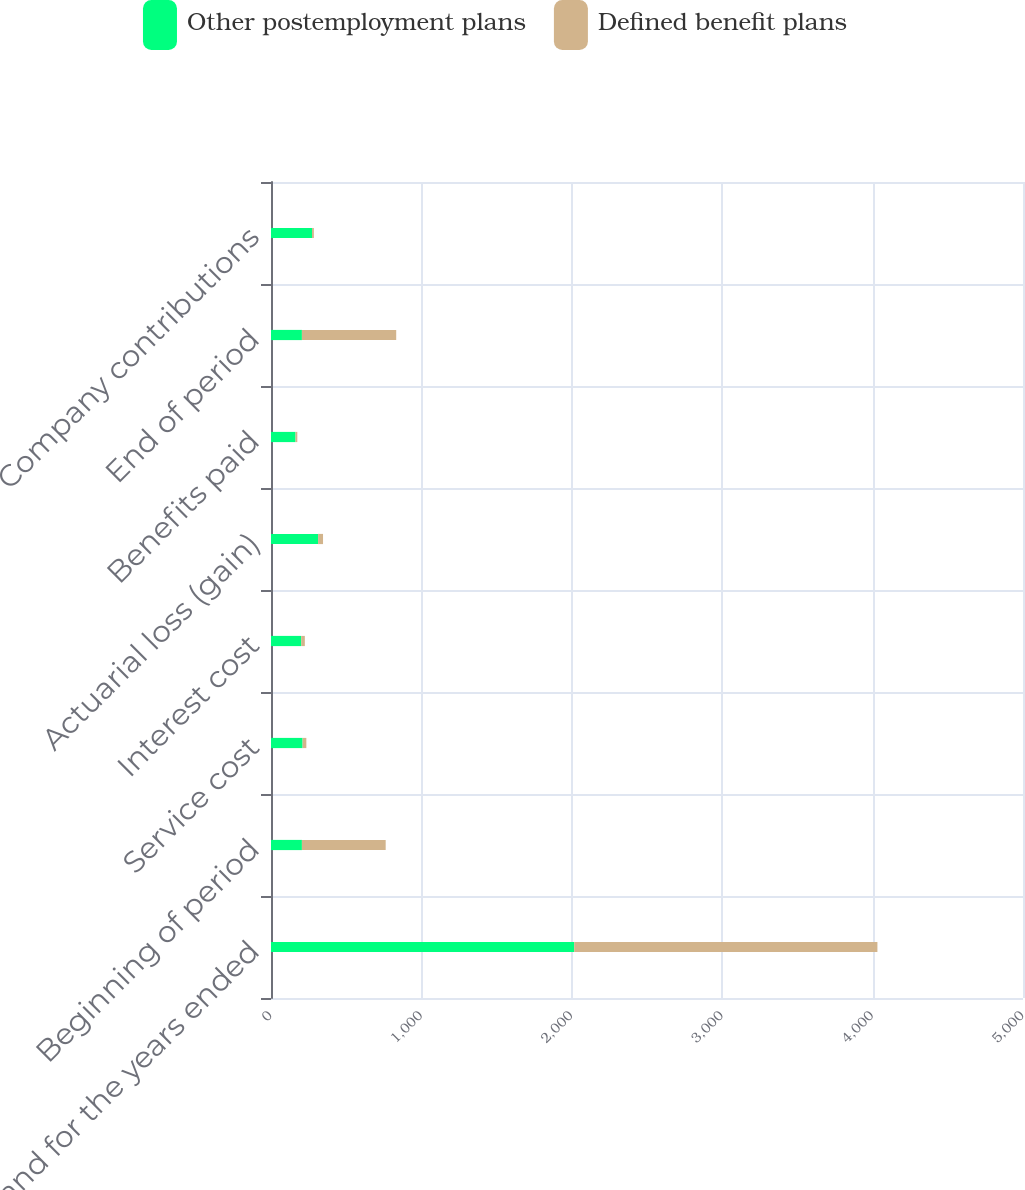Convert chart to OTSL. <chart><loc_0><loc_0><loc_500><loc_500><stacked_bar_chart><ecel><fcel>as of and for the years ended<fcel>Beginning of period<fcel>Service cost<fcel>Interest cost<fcel>Actuarial loss (gain)<fcel>Benefits paid<fcel>End of period<fcel>Company contributions<nl><fcel>Other postemployment plans<fcel>2016<fcel>205.5<fcel>210<fcel>201<fcel>313<fcel>163<fcel>205.5<fcel>273<nl><fcel>Defined benefit plans<fcel>2016<fcel>557<fcel>25<fcel>24<fcel>33<fcel>12<fcel>627<fcel>12<nl></chart> 